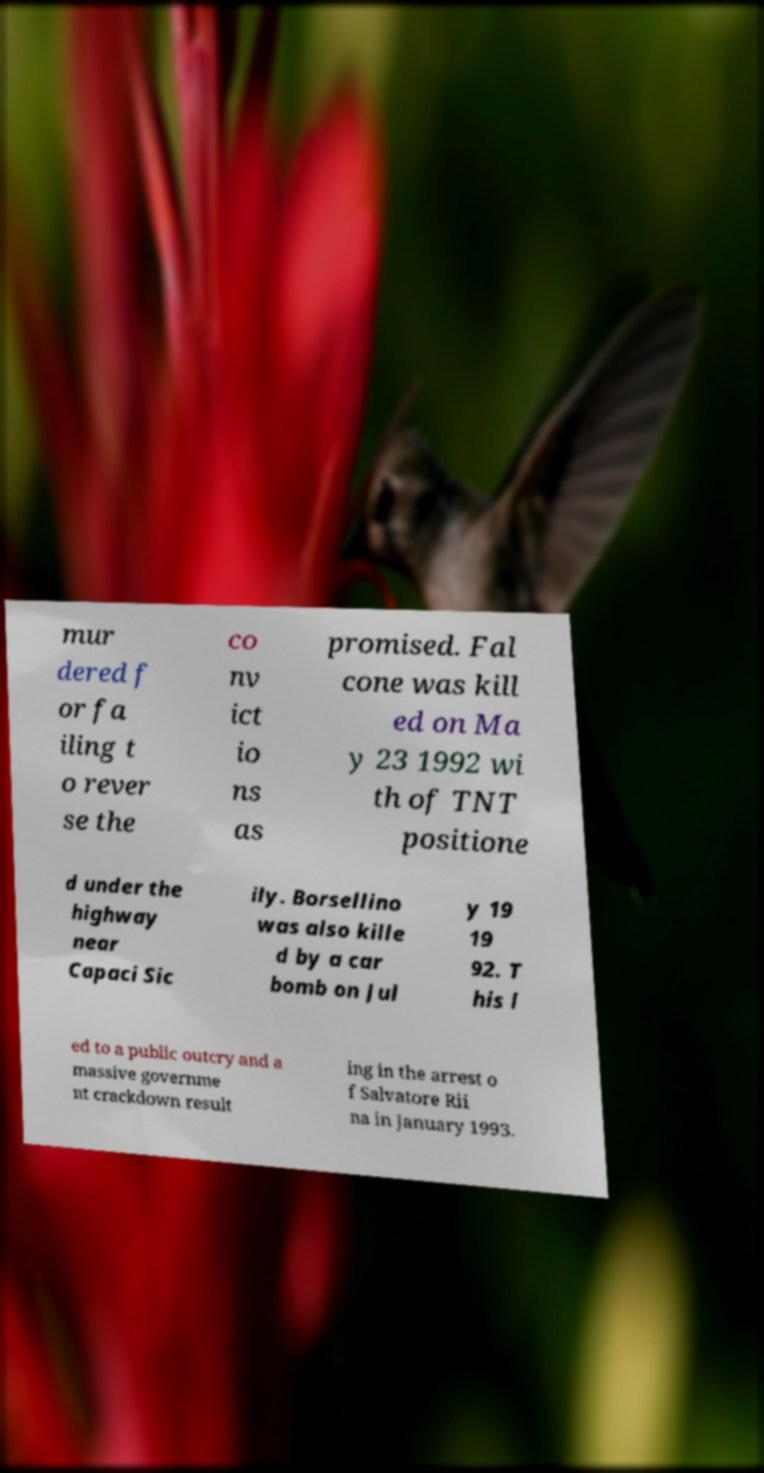What messages or text are displayed in this image? I need them in a readable, typed format. mur dered f or fa iling t o rever se the co nv ict io ns as promised. Fal cone was kill ed on Ma y 23 1992 wi th of TNT positione d under the highway near Capaci Sic ily. Borsellino was also kille d by a car bomb on Jul y 19 19 92. T his l ed to a public outcry and a massive governme nt crackdown result ing in the arrest o f Salvatore Rii na in January 1993. 